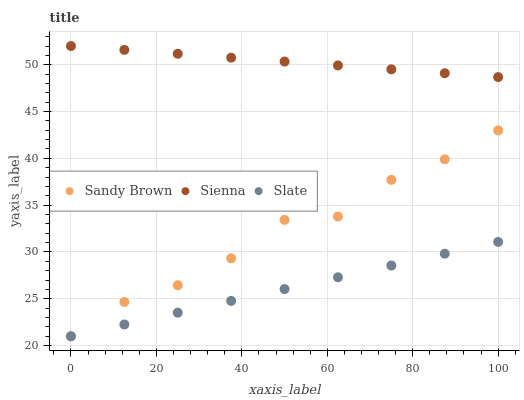Does Slate have the minimum area under the curve?
Answer yes or no. Yes. Does Sienna have the maximum area under the curve?
Answer yes or no. Yes. Does Sandy Brown have the minimum area under the curve?
Answer yes or no. No. Does Sandy Brown have the maximum area under the curve?
Answer yes or no. No. Is Slate the smoothest?
Answer yes or no. Yes. Is Sandy Brown the roughest?
Answer yes or no. Yes. Is Sandy Brown the smoothest?
Answer yes or no. No. Is Slate the roughest?
Answer yes or no. No. Does Slate have the lowest value?
Answer yes or no. Yes. Does Sienna have the highest value?
Answer yes or no. Yes. Does Sandy Brown have the highest value?
Answer yes or no. No. Is Slate less than Sienna?
Answer yes or no. Yes. Is Sienna greater than Slate?
Answer yes or no. Yes. Does Slate intersect Sandy Brown?
Answer yes or no. Yes. Is Slate less than Sandy Brown?
Answer yes or no. No. Is Slate greater than Sandy Brown?
Answer yes or no. No. Does Slate intersect Sienna?
Answer yes or no. No. 